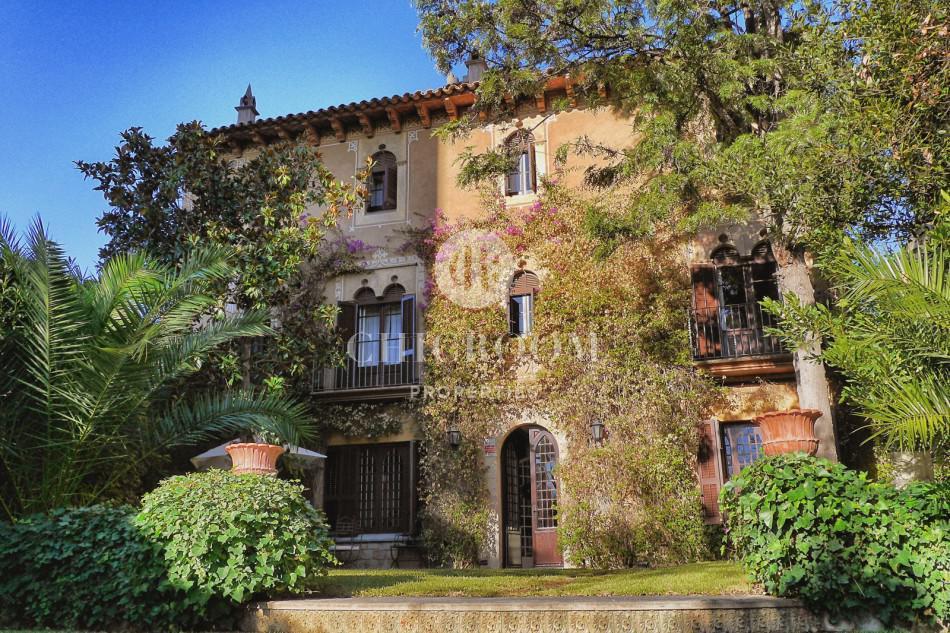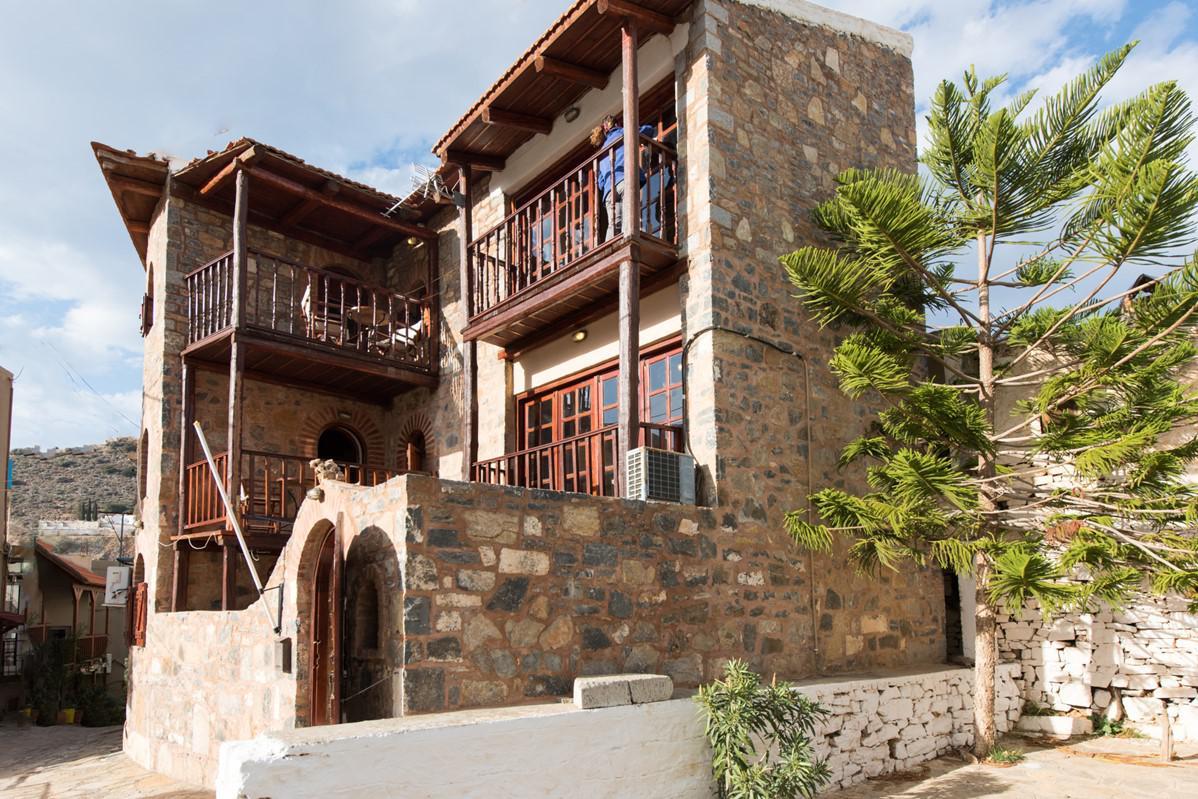The first image is the image on the left, the second image is the image on the right. Examine the images to the left and right. Is the description "There is at least one terrace in one of the images." accurate? Answer yes or no. Yes. 